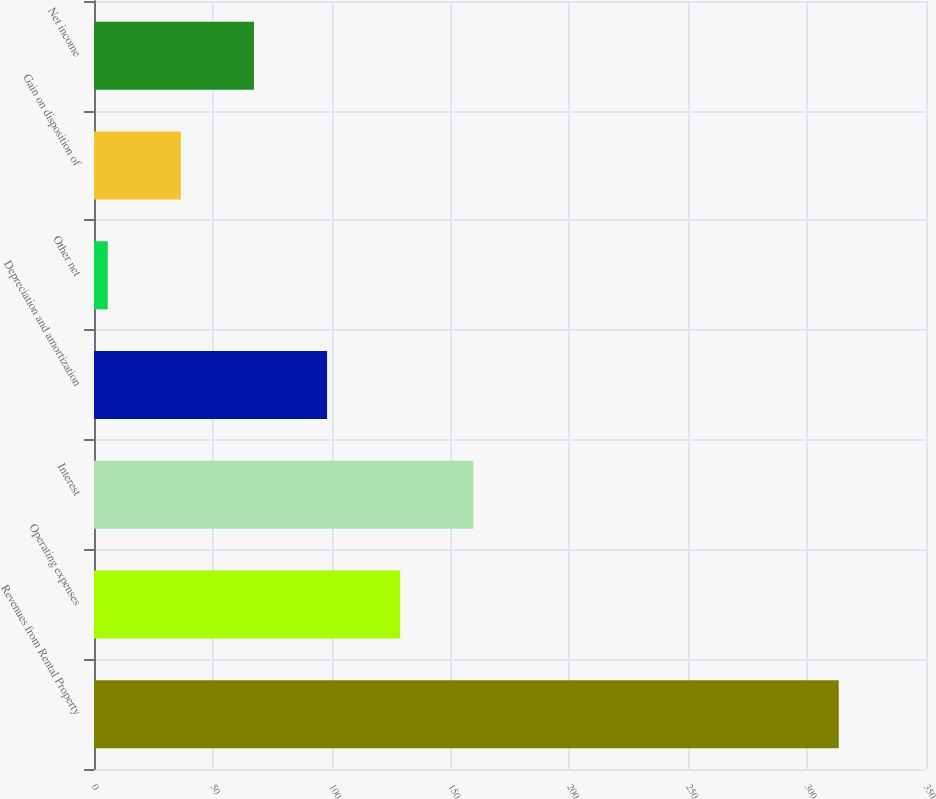<chart> <loc_0><loc_0><loc_500><loc_500><bar_chart><fcel>Revenues from Rental Property<fcel>Operating expenses<fcel>Interest<fcel>Depreciation and amortization<fcel>Other net<fcel>Gain on disposition of<fcel>Net income<nl><fcel>313.3<fcel>128.8<fcel>159.55<fcel>98.05<fcel>5.8<fcel>36.55<fcel>67.3<nl></chart> 